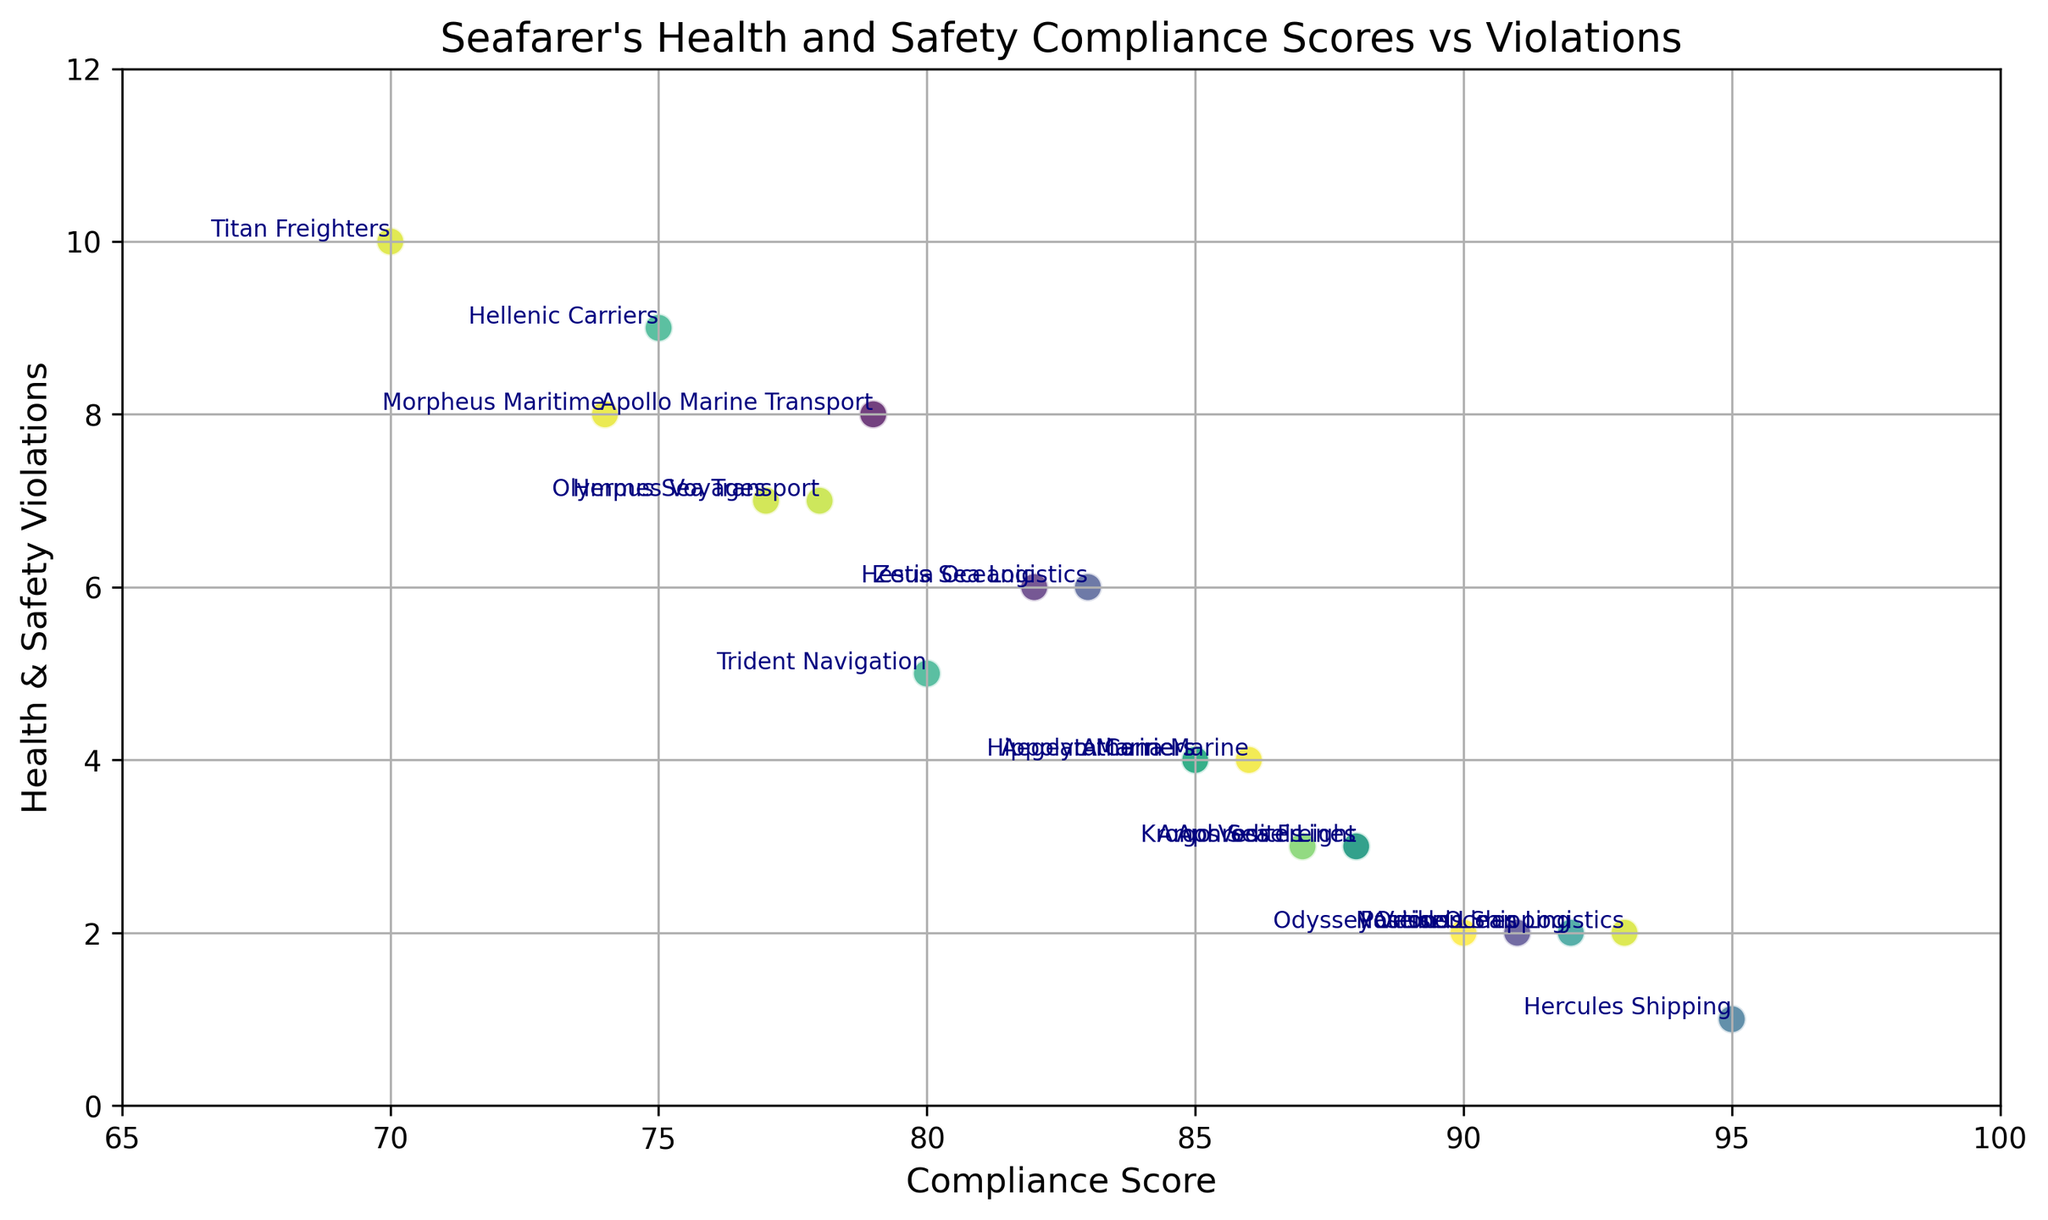What's the highest Health & Safety Violation count recorded? To find the highest Health & Safety Violation, look along the y-axis and identify the highest dot. The point with the company name "Titan Freighters" is at the highest position corresponding to 10.
Answer: 10 Which company has the lowest Compliance Score? Check the x-axis for the lowest value and identify the corresponding company name. The point closest to the lowest x-axis value is "Titan Freighters" at a Compliance Score of 70.
Answer: Titan Freighters Which companies have exactly 2 Health & Safety Violations? Look along the y-axis for the value 2 and find the corresponding company names. The companies present at this violation level are "Poseidon Shipping", "Odyssey Vessels", "Nautilus Lines", and "Orion Ocean Logistics".
Answer: Poseidon Shipping, Odyssey Vessels, Nautilus Lines, Orion Ocean Logistics How many companies have Compliance Scores above 90? Find all points with an x-axis value greater than 90 and count the corresponding company names. The companies are "Poseidon Shipping" (92), "Hercules Shipping" (95), "Nautilus Lines" (91), and "Orion Ocean Logistics" (93). There are 4 companies in total.
Answer: 4 Are there any companies with both a Compliance Score above 90 and Health & Safety Violations equal to or less than 2? Check the data points that have a Compliance Score above 90 and see if their corresponding Health & Safety Violations are ≤ 2. The companies "Poseidon Shipping" (92), "Nautilus Lines" (91), and "Orion Ocean Logistics" (93) all have a Compliance Score above 90 and Health & Safety Violations equal to 2.
Answer: Yes, Poseidon Shipping, Nautilus Lines, Orion Ocean Logistics What is the average Compliance Score of companies with 4 Health & Safety Violations? Identify the Compliance Scores of the companies with 4 Health & Safety Violations and calculate their average. "Aegean Mariners" (85), "Athena Marine" (86), and "Hippolyta Carriers" (85). The average is (85 + 86 + 85) / 3 = 85.33.
Answer: 85.33 Which company has both the highest Compliance Score and the least Health & Safety Violations? To identify the company with the highest Compliance Score and least violations, find the highest point on the x-axis and look for the y-axis value of 1. "Hercules Shipping" has a Compliance Score of 95 and only 1 Health & Safety Violation.
Answer: Hercules Shipping Compare the Compliance Scores of "Aegean Mariners" and "Hippolyta Carriers". Which is greater? Locate "Aegean Mariners" and "Hippolyta Carriers" on the x-axis for their Compliance Scores. "Aegean Mariners" has a score of 85 and "Hippolyta Carriers" also has a score of 85.
Answer: They are equal Which company has the most Health & Safety Violations among those with Compliance Scores between 80 and 90? Identify companies with Compliance Scores between 80 and 90, then find the one with the highest y-value. Possible companies are "Aegean Mariners" (85, 4), "Olympus Sea Transport" (78, 7), "Aphrodite Lines" (88, 3), "Trident Navigation" (80, 5), "Zeus Sea Logistics" (83, 6), "Athena Marine" (86, 4), "Hermes Voyages" (77, 7), "Apollo Marine Transport" (79, 8), "Argo Vessels" (87, 3), "Kronos Sea Freight" (88, 3), and "Hestia Oceanic" (82, 6), "Olympus Sea Transport" and "Hermes Voyages" with 7 violations.
Answer: Olympus Sea Transport, Hermes Voyages What is the combined total of Health & Safety Violations for companies with Compliance Scores below 75? Identify the points with Compliance Scores below 75 and sum their violations. "Hellenic Carriers" (9), "Titan Freighters" (10), and "Morpheus Maritime" (8). The combined total is 9 + 10 + 8 = 27.
Answer: 27 